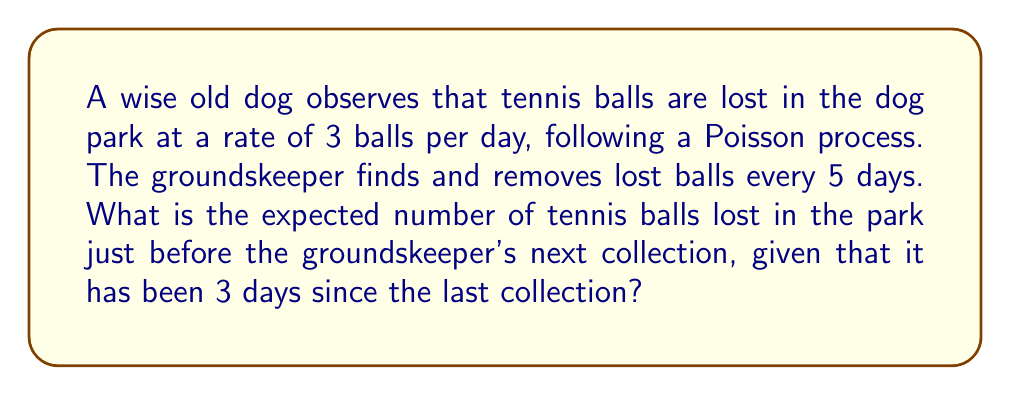Teach me how to tackle this problem. Let's approach this step-by-step, you young pups:

1) We're dealing with a Poisson process here. The rate of ball loss is $\lambda = 3$ balls per day.

2) We want to know the expected number of balls lost in 3 days, as it's been 3 days since the last collection.

3) For a Poisson process, the expected number of events in a time interval $t$ is given by $\lambda t$.

4) In this case, $t = 3$ days.

5) Therefore, the expected number of tennis balls lost is:

   $$E[X] = \lambda t = 3 \text{ balls/day} \times 3 \text{ days} = 9 \text{ balls}$$

6) This result makes sense intuitively: if we're losing an average of 3 balls per day, in 3 days we'd expect to lose about 9 balls.

Remember, pups, in a Poisson process, the events occur independently and at a constant average rate. So, the number of balls lost doesn't depend on how many were lost before or how long until the next collection.
Answer: 9 balls 